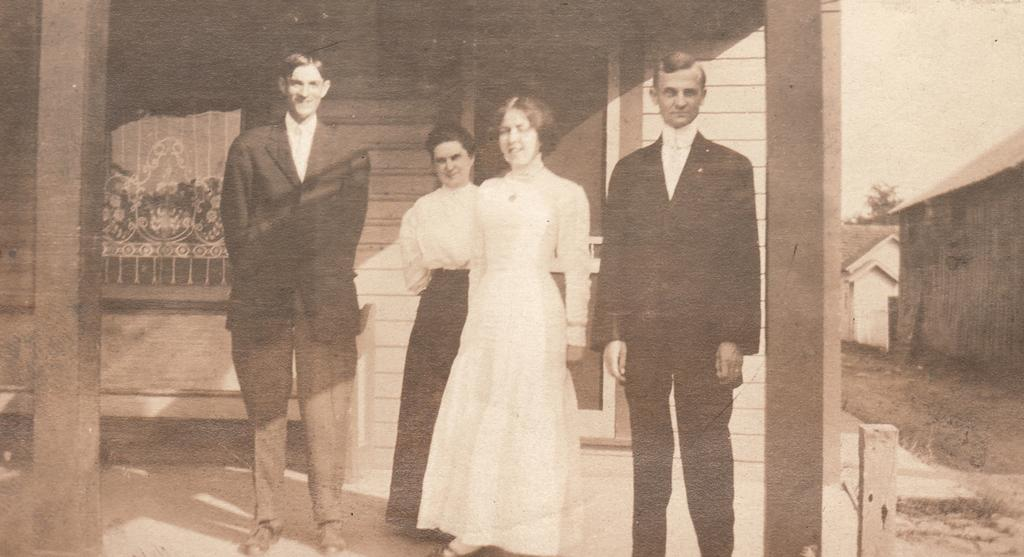What is the color scheme of the image? The image is black and white. How many people are in the image? There are two women and two men in the image. How are the men positioned in relation to the women? The men are on either side of the women. What can be seen on either side of the men? There are pillars on either side of the men. What is visible in the background of the image? There is a house in the background of the image. What type of slope can be seen in the image? There is no slope present in the image. Can you read the letter that the women are holding in the image? There is no letter visible in the image; the women are not holding anything. 